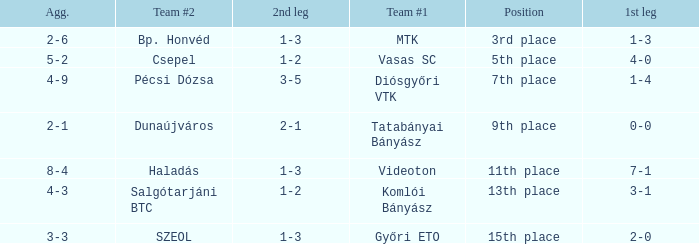What is the team #1 with an 11th place position? Videoton. 